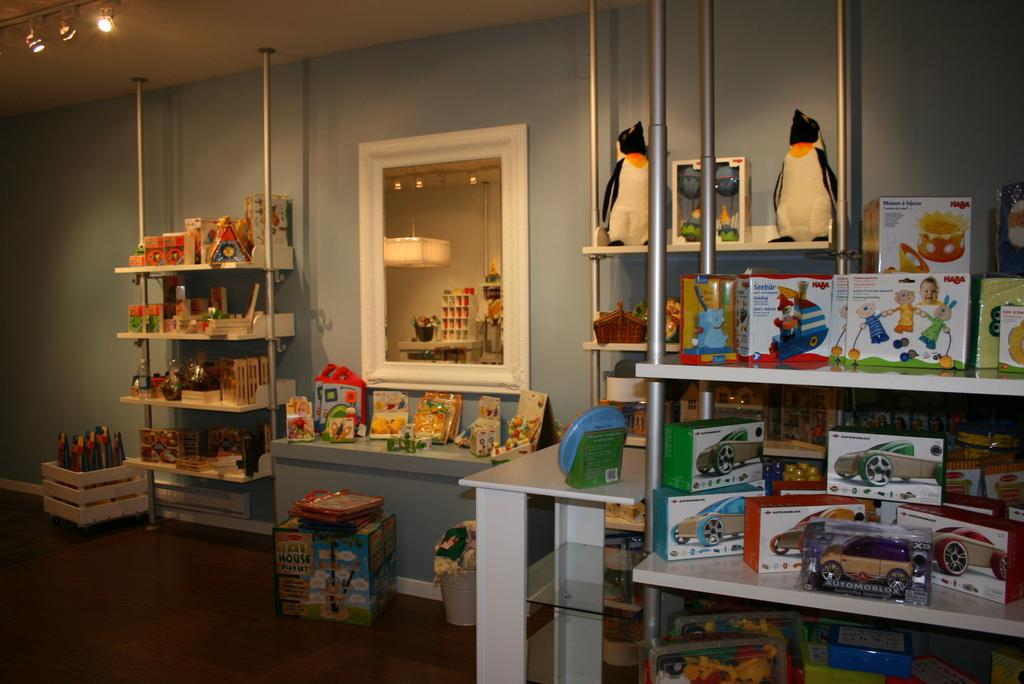<image>
Write a terse but informative summary of the picture. The inside of a toy store including a Tree House Play Set. 